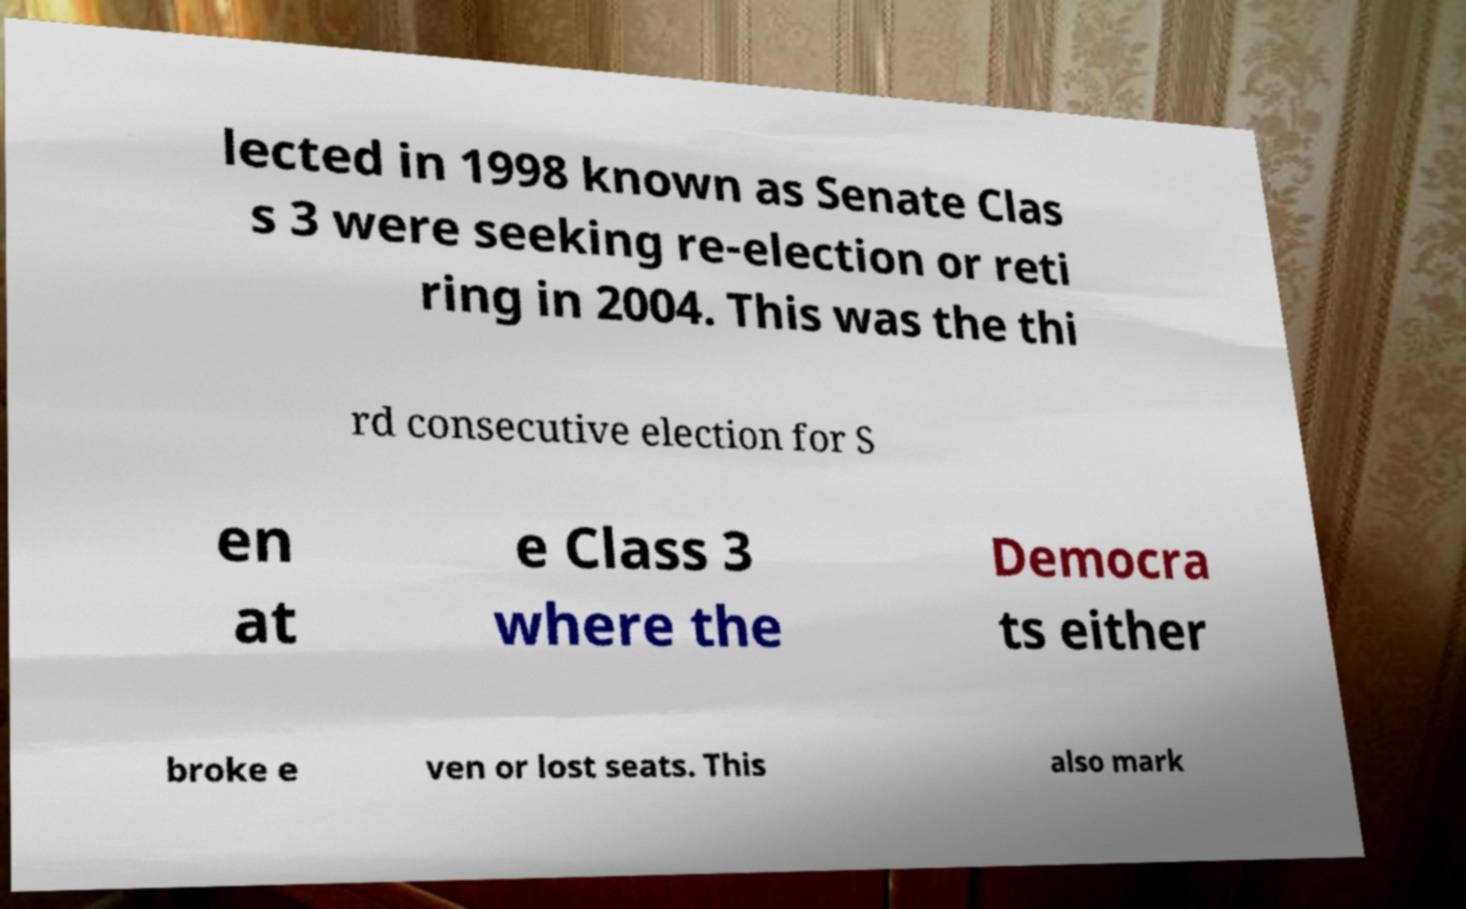Can you accurately transcribe the text from the provided image for me? lected in 1998 known as Senate Clas s 3 were seeking re-election or reti ring in 2004. This was the thi rd consecutive election for S en at e Class 3 where the Democra ts either broke e ven or lost seats. This also mark 